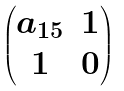Convert formula to latex. <formula><loc_0><loc_0><loc_500><loc_500>\begin{pmatrix} a _ { 1 5 } & 1 \\ 1 & 0 \end{pmatrix}</formula> 